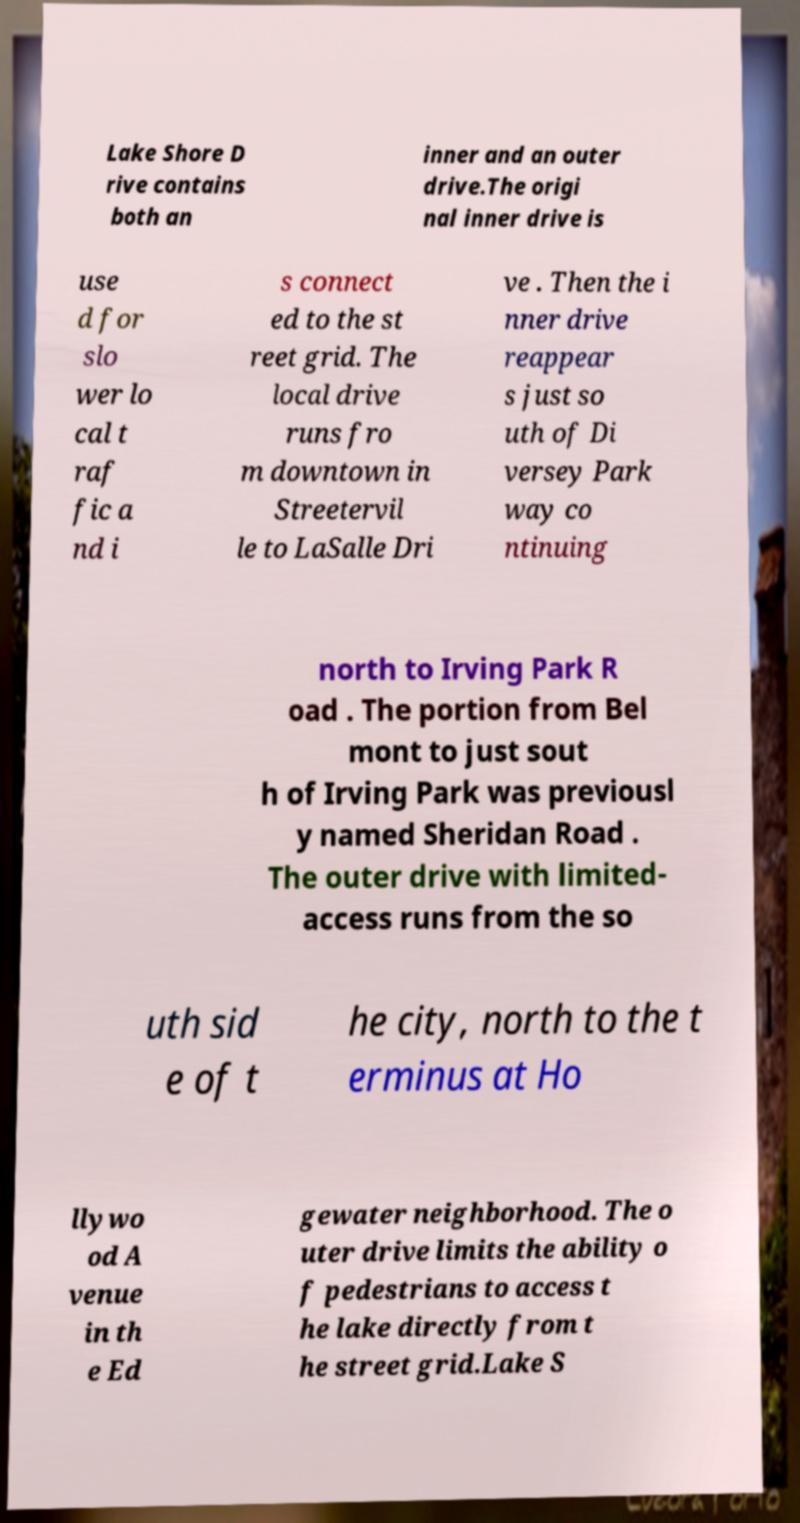I need the written content from this picture converted into text. Can you do that? Lake Shore D rive contains both an inner and an outer drive.The origi nal inner drive is use d for slo wer lo cal t raf fic a nd i s connect ed to the st reet grid. The local drive runs fro m downtown in Streetervil le to LaSalle Dri ve . Then the i nner drive reappear s just so uth of Di versey Park way co ntinuing north to Irving Park R oad . The portion from Bel mont to just sout h of Irving Park was previousl y named Sheridan Road . The outer drive with limited- access runs from the so uth sid e of t he city, north to the t erminus at Ho llywo od A venue in th e Ed gewater neighborhood. The o uter drive limits the ability o f pedestrians to access t he lake directly from t he street grid.Lake S 